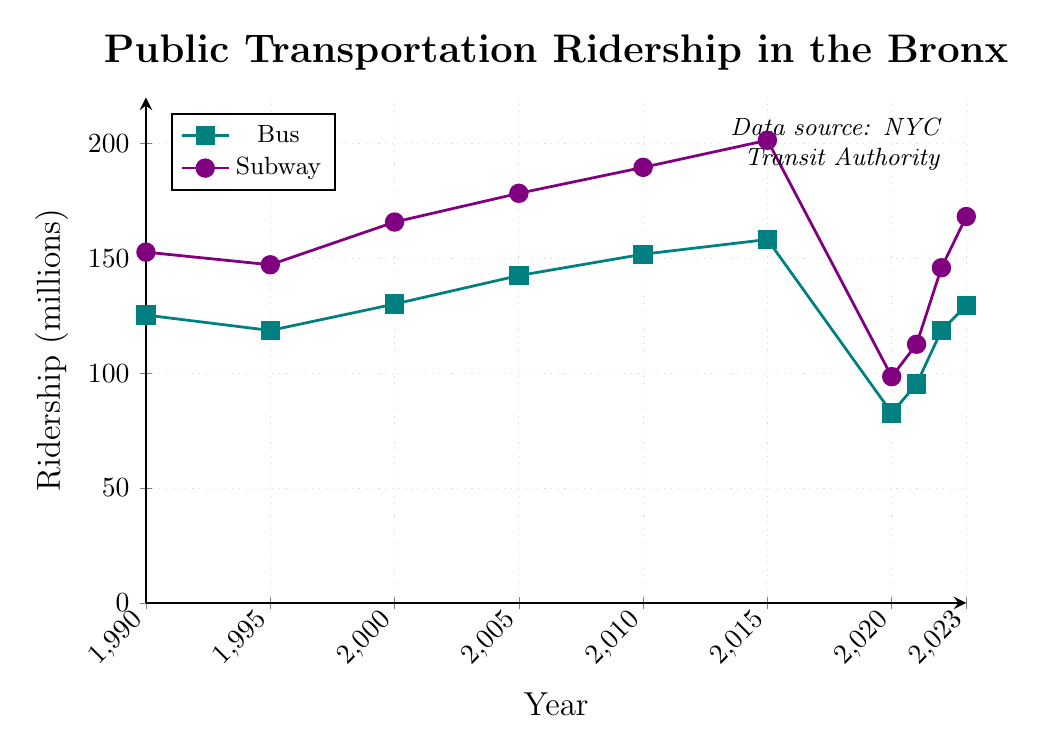Which year had the peak bus ridership? Looking at the line representing bus ridership, the highest point occurs in 2015.
Answer: 2015 How much did subway ridership increase from 1990 to 2010? In 1990, subway ridership was 152.7 million, and in 2010, it was 189.6 million. The increase is 189.6 - 152.7 = 36.9 million.
Answer: 36.9 million In which year did bus ridership experience the greatest drop compared to the previous year? By examining the bus ridership values year to year, the largest decline occurred between 2015 and 2020, dropping from 158.2 million to 82.7 million.
Answer: 2020 When did subway ridership first surpass 200 million? Checking the subway ridership line, the first time it goes above 200 million is in 2015.
Answer: 2015 What was the difference in bus ridership between the highest and lowest years shown? The highest bus ridership was in 2015 with 158.2 million, and the lowest was in 2020 with 82.7 million. The difference is 158.2 - 82.7 = 75.5 million.
Answer: 75.5 million Comparing 2020, which had more ridership, buses or subways, and by how much? For 2020, bus ridership was 82.7 million, and subway ridership was 98.5 million. Subways had 98.5 - 82.7 = 15.8 million more ridership.
Answer: Subways by 15.8 million Was there any year where bus and subway ridership were equal? Scanning the lines for both bus and subway, no point indicates that the bus and subway ridership numbers matched exactly.
Answer: No What was the average bus ridership from 1990 to 2023? Summing up the bus ridership values (125.3, 118.6, 130.1, 142.5, 151.8, 158.2, 82.7, 95.3, 118.6, 129.4) and dividing by the number of years: (125.3 + 118.6 + 130.1 + 142.5 + 151.8 + 158.2 + 82.7 + 95.3 + 118.6 + 129.4)/10 = 1252.5/10 = 125.25 million.
Answer: 125.25 million Which had a larger ridership in 2021, bus or subway? For 2021, the bus ridership was 95.3 million and subway ridership was 112.6 million. Subways had a larger ridership.
Answer: Subways Which mode of transport saw a more significant drop during 2020? In 2020, the bus ridership dropped from 158.2 million in 2015 to 82.7 million (a decrease of 75.5 million), and subway ridership dropped from 201.4 million to 98.5 million (a decrease of 102.9 million). Subway saw a more significant drop.
Answer: Subway 